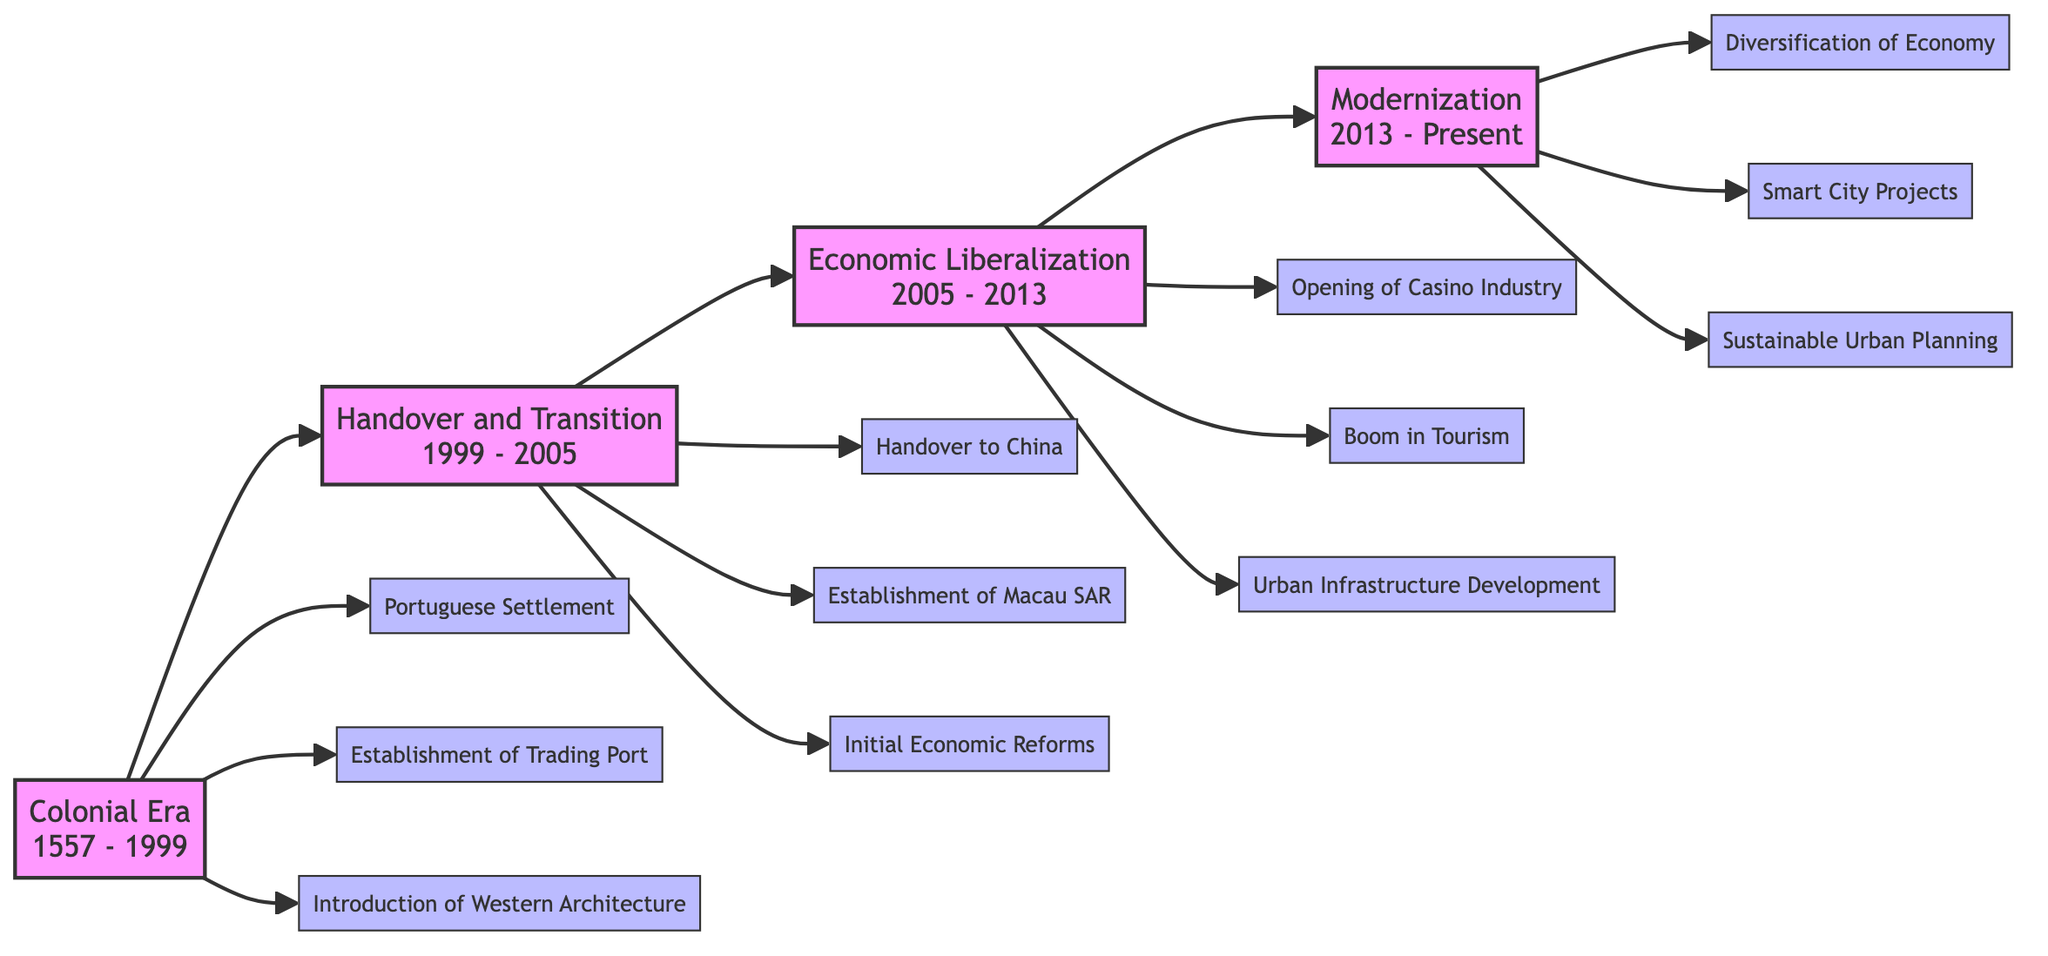What is the first phase of urban development in Macau? According to the flowchart, the first phase is labeled as "Colonial Era," which spans from 1557 to 1999.
Answer: Colonial Era What period does the "Modernization" phase cover? By examining the flowchart, "Modernization" is indicated to occur from 2013 to Present.
Answer: 2013 - Present How many key events are associated with the "Economic Liberalization" phase? The flowchart lists three key events under this phase: Opening of Casino Industry, Boom in Tourism, and Urban Infrastructure Development. Therefore, the total is three key events.
Answer: 3 What event marks the transition from the "Handover and Transition" phase to the next phase? The transition from "Handover and Transition" to "Economic Liberalization" is marked by the event that does not specify one but flows directly with the arrow to the next phase. The relevant phase change is not directly tied to a specific event but follows the established timeline.
Answer: Economic Liberalization What phase follows the "Colonial Era"? Following the flowchart, the phase that immediately follows "Colonial Era" is "Handover and Transition."
Answer: Handover and Transition What is one key event under the "Modernization" phase? The flowchart mentions three key events under "Modernization"; one of them is "Diversification of Economy." This serves as a concrete answer based on the listed events.
Answer: Diversification of Economy Which phase includes the event "Handover to China"? The event "Handover to China" is specifically listed under the "Handover and Transition" phase. Therefore, this phase directly corresponds to this event.
Answer: Handover and Transition How does the "Economic Liberalization" phase impact urban infrastructure? The flowchart indicates that one of the key events during "Economic Liberalization" is "Urban Infrastructure Development," thus directly connecting the phase to the impact on urban infrastructure during this period.
Answer: Urban Infrastructure Development What is the last key event listed in the flowchart? The flowchart concludes with "Sustainable Urban Planning," which is the final event listed under the "Modernization" phase.
Answer: Sustainable Urban Planning 